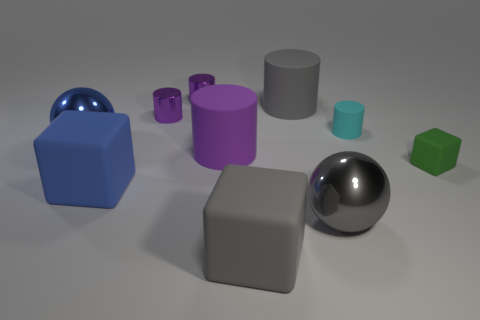There is a large gray rubber thing that is in front of the large gray shiny object; what is its shape?
Keep it short and to the point. Cube. Is the number of tiny cyan rubber things to the left of the large blue sphere the same as the number of gray rubber things right of the tiny green matte object?
Make the answer very short. Yes. What number of objects are either blue shiny balls or matte cubes that are behind the large gray metallic ball?
Offer a terse response. 3. There is a small thing that is both right of the large gray block and behind the large blue ball; what shape is it?
Offer a very short reply. Cylinder. What material is the green thing in front of the large gray matte object behind the cyan matte cylinder?
Your answer should be compact. Rubber. Do the sphere to the right of the blue metallic ball and the large purple cylinder have the same material?
Provide a short and direct response. No. What is the size of the cube that is on the right side of the tiny cyan matte cylinder?
Your answer should be compact. Small. Is there a block behind the rubber thing that is left of the big purple matte cylinder?
Provide a succinct answer. Yes. Do the large rubber cylinder that is on the right side of the large gray block and the cube in front of the gray metal sphere have the same color?
Make the answer very short. Yes. What color is the tiny rubber cylinder?
Your response must be concise. Cyan. 